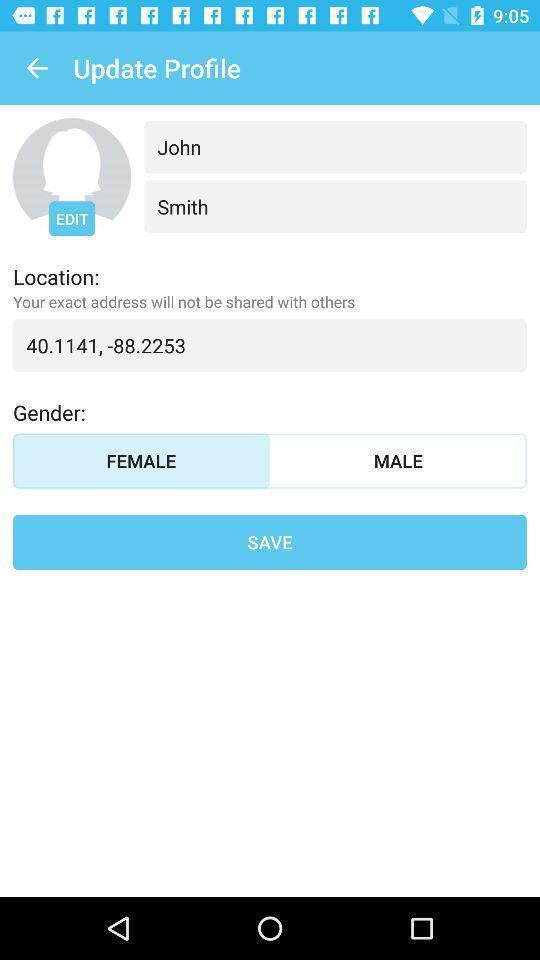Explain the elements present in this screenshot. Screen displaying user profile information. 